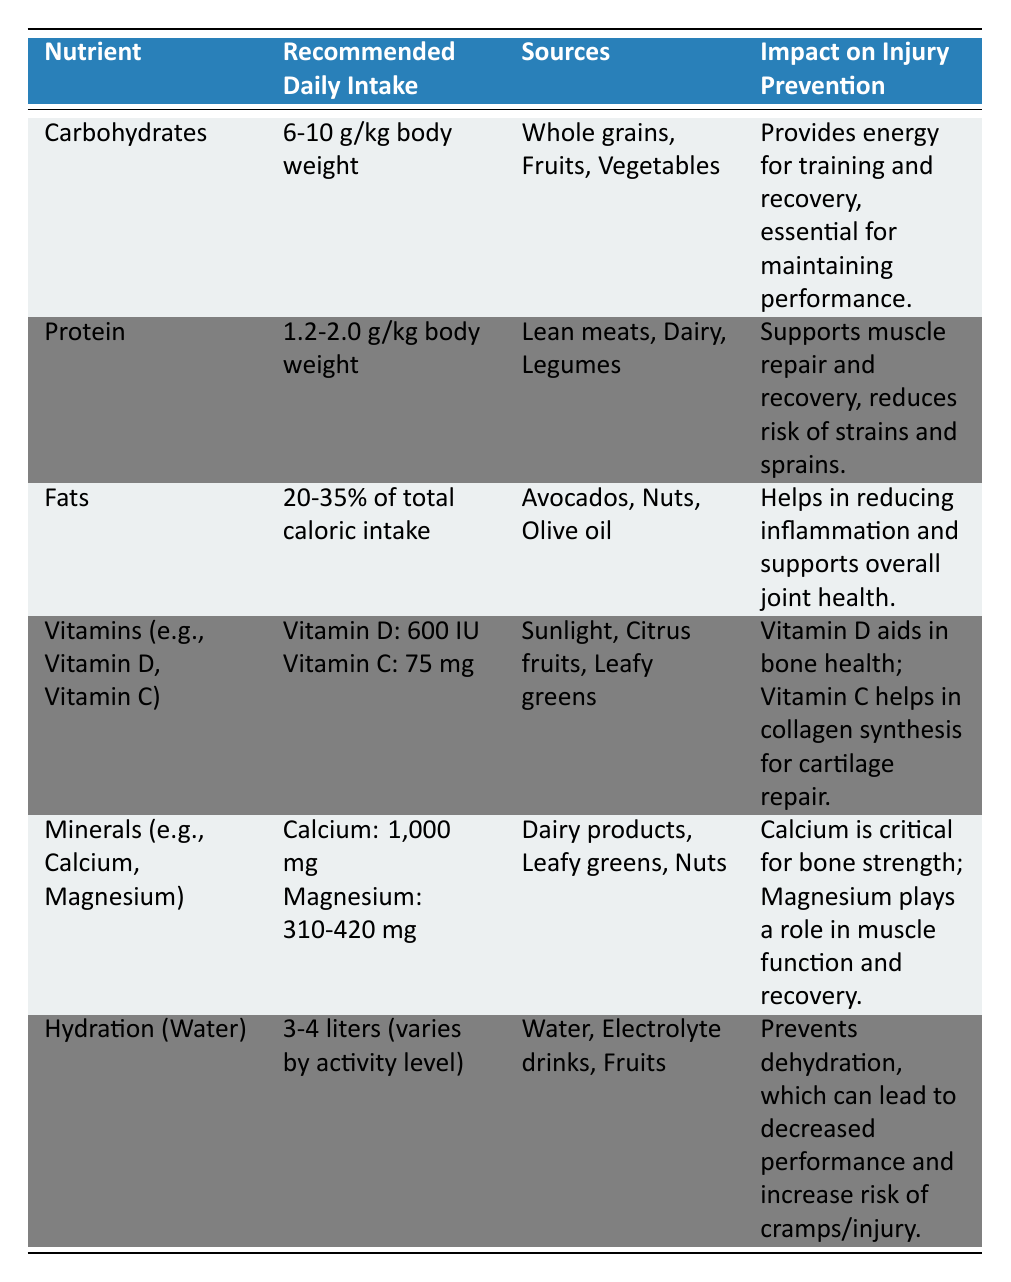What is the recommended daily intake of carbohydrates? The table states that the recommended daily intake of carbohydrates is 6-10 g/kg of body weight.
Answer: 6-10 g/kg body weight What sources of protein are listed? The sources of protein mentioned in the table are lean meats, dairy, and legumes.
Answer: Lean meats, dairy, legumes Does fats help with inflammation? Yes, the table indicates that fats help in reducing inflammation and support overall joint health.
Answer: Yes What is the recommended daily intake of calcium? According to the table, the recommended daily intake of calcium is 1,000 mg.
Answer: 1,000 mg Which nutrient has a direct impact on muscle repair and recovery? The table mentions that protein supports muscle repair and recovery.
Answer: Protein What are the sources of vitamins mentioned in the table? The sources of vitamins listed are sunlight, citrus fruits, and leafy greens.
Answer: Sunlight, citrus fruits, leafy greens Calculate the total recommended daily intake for Vitamin D and Vitamin C together. The recommended intake for Vitamin D is 600 IU and for Vitamin C is 75 mg. Adding them together gives 600 + 75 = 675 (note: different units).
Answer: 675 (with different units) Is hydration essential only during high-intensity training? No, the table indicates that hydration is essential to prevent dehydration regardless of activity level, thus it’s important for all training intensities.
Answer: No Which nutrient's intake is associated with maintaining performance during training? The table states that carbohydrates provide energy for training and recovery, thus maintaining performance.
Answer: Carbohydrates If someone weighs 70 kg, how many grams of protein should they consume daily at the recommended intake? For someone weighing 70 kg with a protein intake range of 1.2-2.0 g/kg, the calculation gives a range of 70 * 1.2 = 84 g and 70 * 2.0 = 140 g. So the range is 84-140 g.
Answer: 84-140 g What impact does Vitamin C have on injury prevention? The table indicates that Vitamin C helps in collagen synthesis for cartilage repair, which aids in injury prevention.
Answer: Aids in collagen synthesis for cartilage repair 